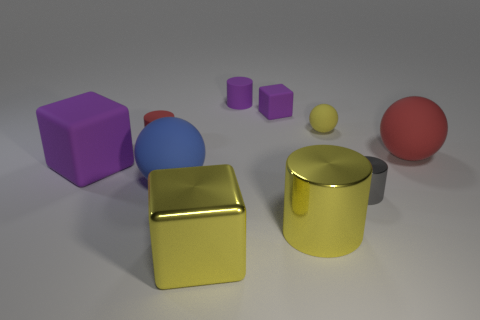Subtract all spheres. How many objects are left? 7 Add 1 purple cylinders. How many purple cylinders exist? 2 Subtract 0 green spheres. How many objects are left? 10 Subtract all cyan shiny blocks. Subtract all yellow shiny cubes. How many objects are left? 9 Add 4 large red matte objects. How many large red matte objects are left? 5 